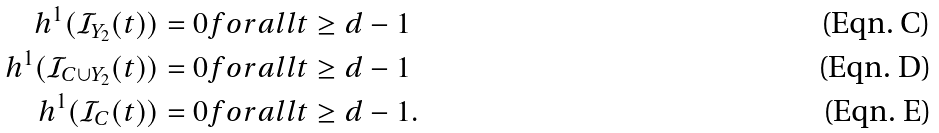Convert formula to latex. <formula><loc_0><loc_0><loc_500><loc_500>h ^ { 1 } ( \mathcal { I } _ { Y _ { 2 } } ( t ) ) & = 0 f o r a l l t \geq d - 1 \\ h ^ { 1 } ( \mathcal { I } _ { C \cup Y _ { 2 } } ( t ) ) & = 0 f o r a l l t \geq d - 1 \\ h ^ { 1 } ( \mathcal { I } _ { C } ( t ) ) & = 0 f o r a l l t \geq d - 1 .</formula> 